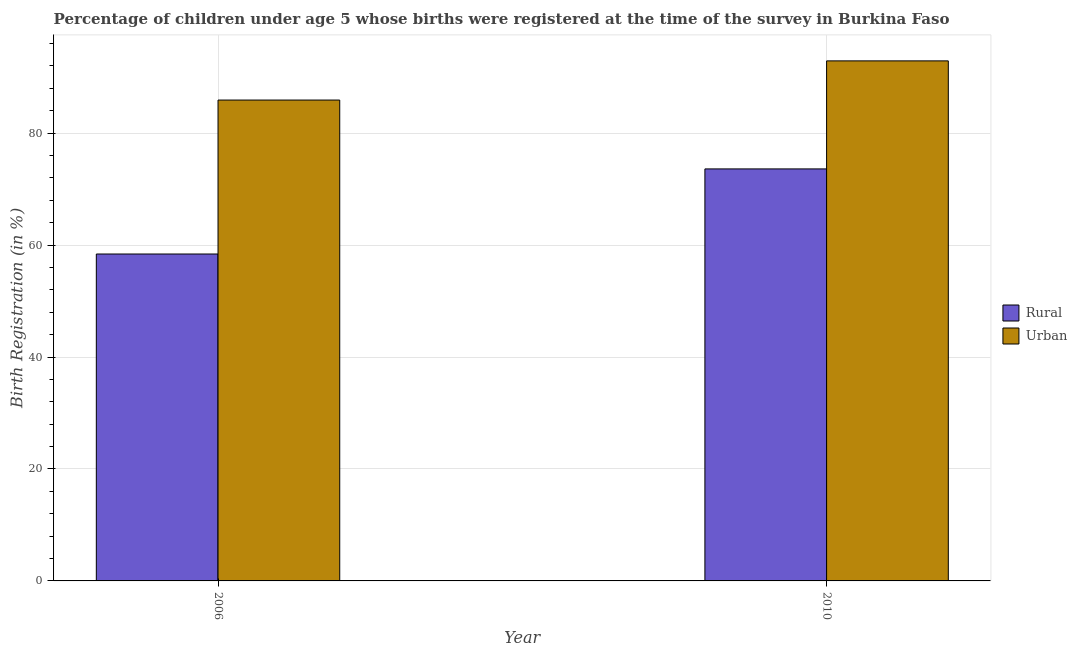How many different coloured bars are there?
Ensure brevity in your answer.  2. Are the number of bars per tick equal to the number of legend labels?
Give a very brief answer. Yes. How many bars are there on the 1st tick from the right?
Your answer should be compact. 2. What is the label of the 2nd group of bars from the left?
Your answer should be compact. 2010. What is the urban birth registration in 2006?
Give a very brief answer. 85.9. Across all years, what is the maximum urban birth registration?
Your response must be concise. 92.9. Across all years, what is the minimum rural birth registration?
Keep it short and to the point. 58.4. In which year was the urban birth registration minimum?
Your answer should be compact. 2006. What is the total urban birth registration in the graph?
Keep it short and to the point. 178.8. What is the difference between the urban birth registration in 2006 and that in 2010?
Offer a terse response. -7. What is the difference between the urban birth registration in 2006 and the rural birth registration in 2010?
Your response must be concise. -7. In the year 2010, what is the difference between the urban birth registration and rural birth registration?
Your answer should be very brief. 0. What is the ratio of the rural birth registration in 2006 to that in 2010?
Keep it short and to the point. 0.79. What does the 1st bar from the left in 2010 represents?
Keep it short and to the point. Rural. What does the 2nd bar from the right in 2006 represents?
Provide a succinct answer. Rural. How many bars are there?
Your answer should be compact. 4. Are all the bars in the graph horizontal?
Offer a very short reply. No. What is the difference between two consecutive major ticks on the Y-axis?
Offer a terse response. 20. Does the graph contain any zero values?
Keep it short and to the point. No. Where does the legend appear in the graph?
Your response must be concise. Center right. How are the legend labels stacked?
Offer a terse response. Vertical. What is the title of the graph?
Provide a succinct answer. Percentage of children under age 5 whose births were registered at the time of the survey in Burkina Faso. What is the label or title of the Y-axis?
Offer a terse response. Birth Registration (in %). What is the Birth Registration (in %) in Rural in 2006?
Offer a very short reply. 58.4. What is the Birth Registration (in %) in Urban in 2006?
Offer a terse response. 85.9. What is the Birth Registration (in %) in Rural in 2010?
Offer a terse response. 73.6. What is the Birth Registration (in %) in Urban in 2010?
Your response must be concise. 92.9. Across all years, what is the maximum Birth Registration (in %) of Rural?
Ensure brevity in your answer.  73.6. Across all years, what is the maximum Birth Registration (in %) of Urban?
Your answer should be compact. 92.9. Across all years, what is the minimum Birth Registration (in %) in Rural?
Keep it short and to the point. 58.4. Across all years, what is the minimum Birth Registration (in %) in Urban?
Your answer should be compact. 85.9. What is the total Birth Registration (in %) of Rural in the graph?
Keep it short and to the point. 132. What is the total Birth Registration (in %) of Urban in the graph?
Give a very brief answer. 178.8. What is the difference between the Birth Registration (in %) of Rural in 2006 and that in 2010?
Your answer should be compact. -15.2. What is the difference between the Birth Registration (in %) in Rural in 2006 and the Birth Registration (in %) in Urban in 2010?
Provide a short and direct response. -34.5. What is the average Birth Registration (in %) of Urban per year?
Offer a terse response. 89.4. In the year 2006, what is the difference between the Birth Registration (in %) of Rural and Birth Registration (in %) of Urban?
Give a very brief answer. -27.5. In the year 2010, what is the difference between the Birth Registration (in %) in Rural and Birth Registration (in %) in Urban?
Provide a short and direct response. -19.3. What is the ratio of the Birth Registration (in %) in Rural in 2006 to that in 2010?
Ensure brevity in your answer.  0.79. What is the ratio of the Birth Registration (in %) of Urban in 2006 to that in 2010?
Ensure brevity in your answer.  0.92. What is the difference between the highest and the second highest Birth Registration (in %) of Rural?
Your answer should be compact. 15.2. What is the difference between the highest and the second highest Birth Registration (in %) in Urban?
Provide a short and direct response. 7. 